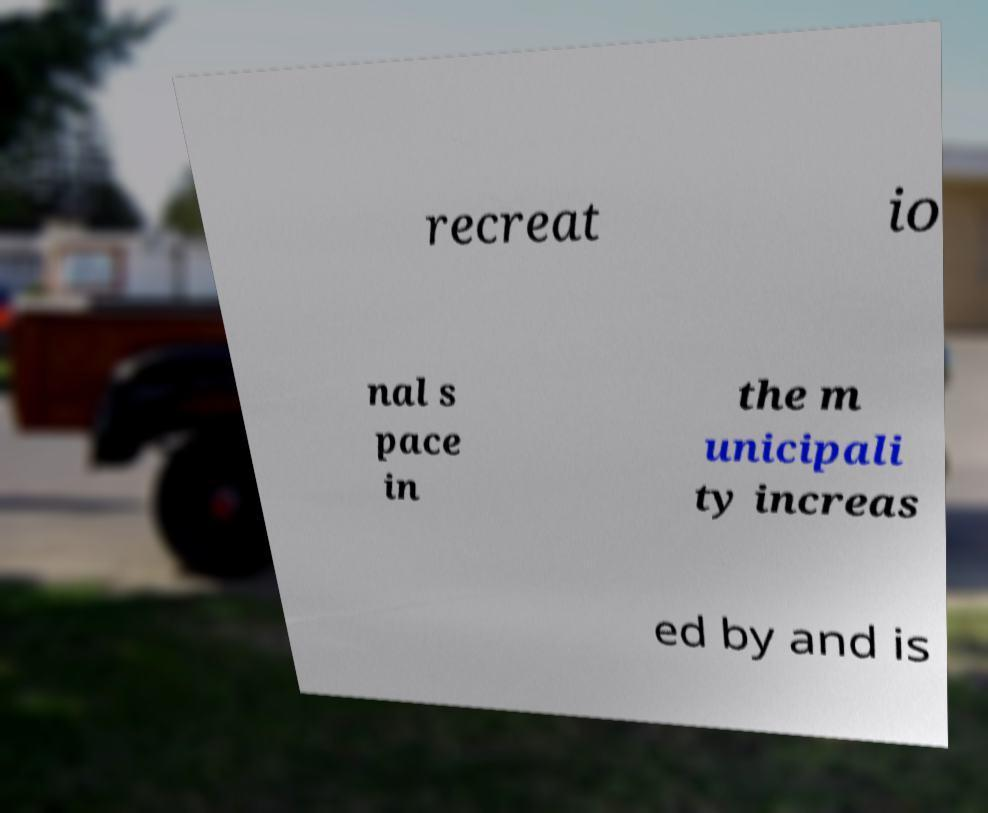Could you extract and type out the text from this image? recreat io nal s pace in the m unicipali ty increas ed by and is 